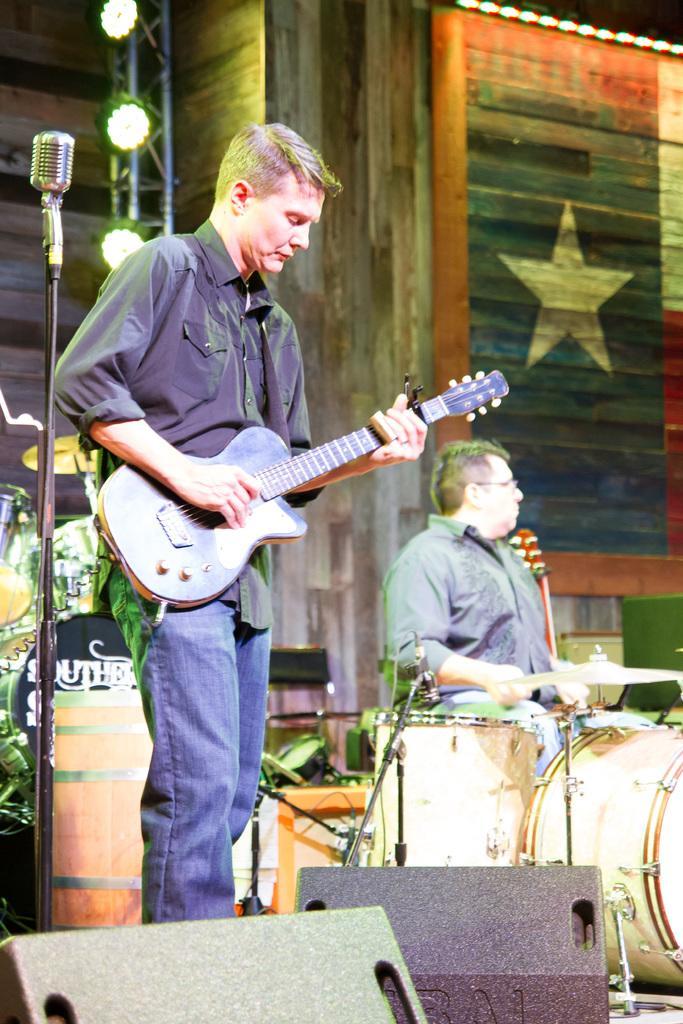Could you give a brief overview of what you see in this image? In this image I can see two people. One person is playing guitar and another one is playing drum set. In front of them there is a mic. At the back there is a building and the lights 